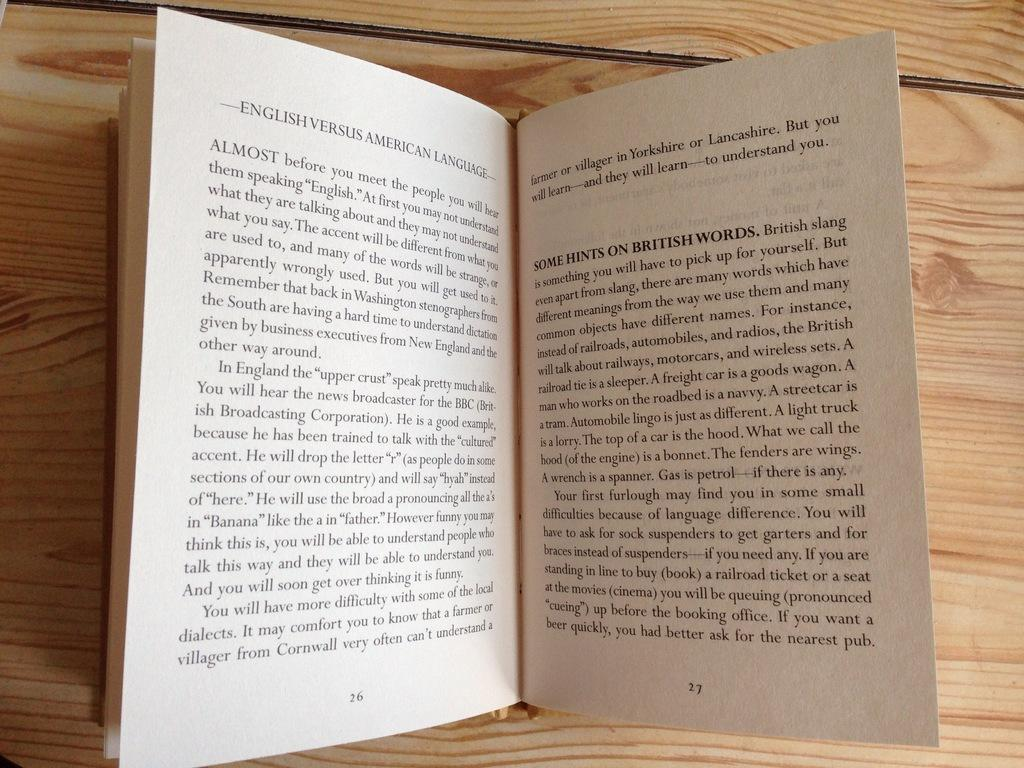<image>
Summarize the visual content of the image. The book English Versus American Language is open to pages 26 an 27. 